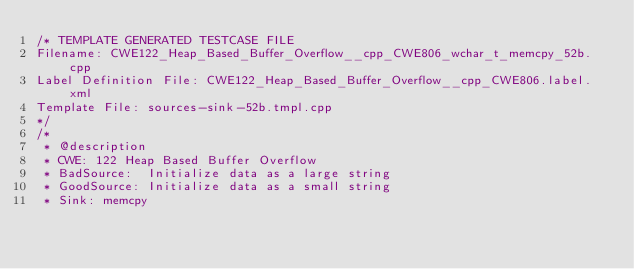<code> <loc_0><loc_0><loc_500><loc_500><_C++_>/* TEMPLATE GENERATED TESTCASE FILE
Filename: CWE122_Heap_Based_Buffer_Overflow__cpp_CWE806_wchar_t_memcpy_52b.cpp
Label Definition File: CWE122_Heap_Based_Buffer_Overflow__cpp_CWE806.label.xml
Template File: sources-sink-52b.tmpl.cpp
*/
/*
 * @description
 * CWE: 122 Heap Based Buffer Overflow
 * BadSource:  Initialize data as a large string
 * GoodSource: Initialize data as a small string
 * Sink: memcpy</code> 